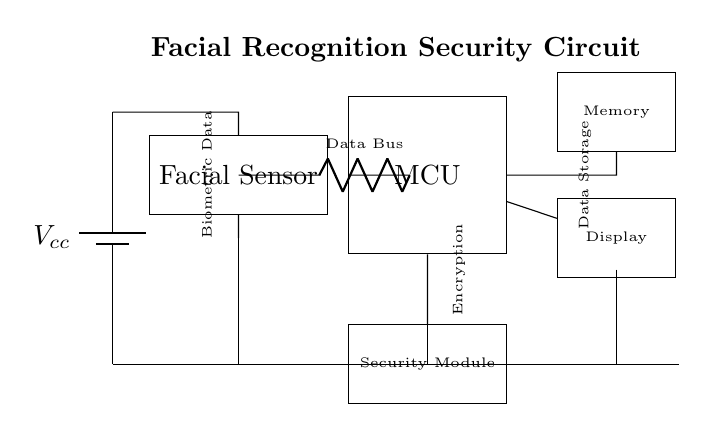What is the primary function of the facial sensor? The primary function of the facial sensor is to capture biometric data, specifically recognizing facial features for security purposes.
Answer: Capture biometric data Which component stores data? The memory component is responsible for storing data. It is connected to the microcontroller, indicating it holds the information needed for processing.
Answer: Memory What power supply is used in the circuit? The battery labeled as Vcc supplies power to the entire circuit, providing the necessary voltage for operation.
Answer: Vcc What does the security module do? The security module is responsible for encryption, safeguarding the biometric data processed from the facial sensor and ensuring secure access.
Answer: Encryption How many main components are connected to the microcontroller? There are four main components connected to the microcontroller: the facial sensor, memory, display, and security module.
Answer: Four What type of circuit is this? This is a biometric sensor circuit designed specifically for facial recognition security in mobile devices, involving various components for data processing and security management.
Answer: Biometric sensor circuit 